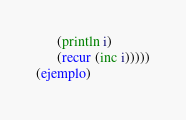<code> <loc_0><loc_0><loc_500><loc_500><_Clojure_>      (println i)
      (recur (inc i)))))
(ejemplo)</code> 